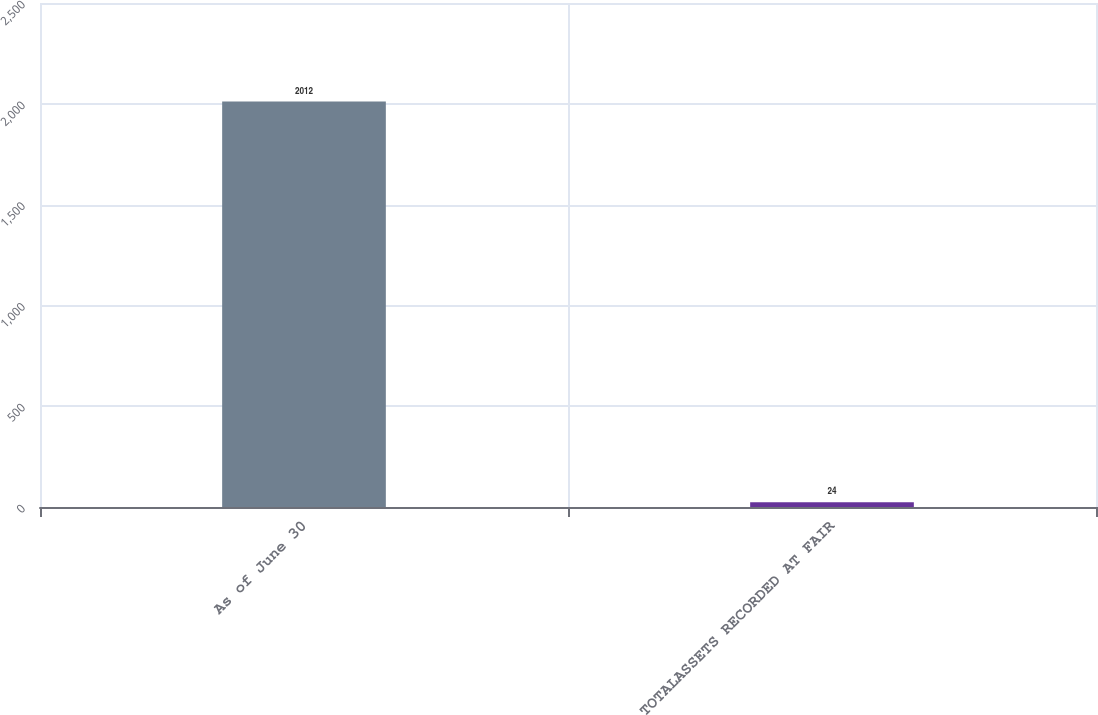<chart> <loc_0><loc_0><loc_500><loc_500><bar_chart><fcel>As of June 30<fcel>TOTALASSETS RECORDED AT FAIR<nl><fcel>2012<fcel>24<nl></chart> 